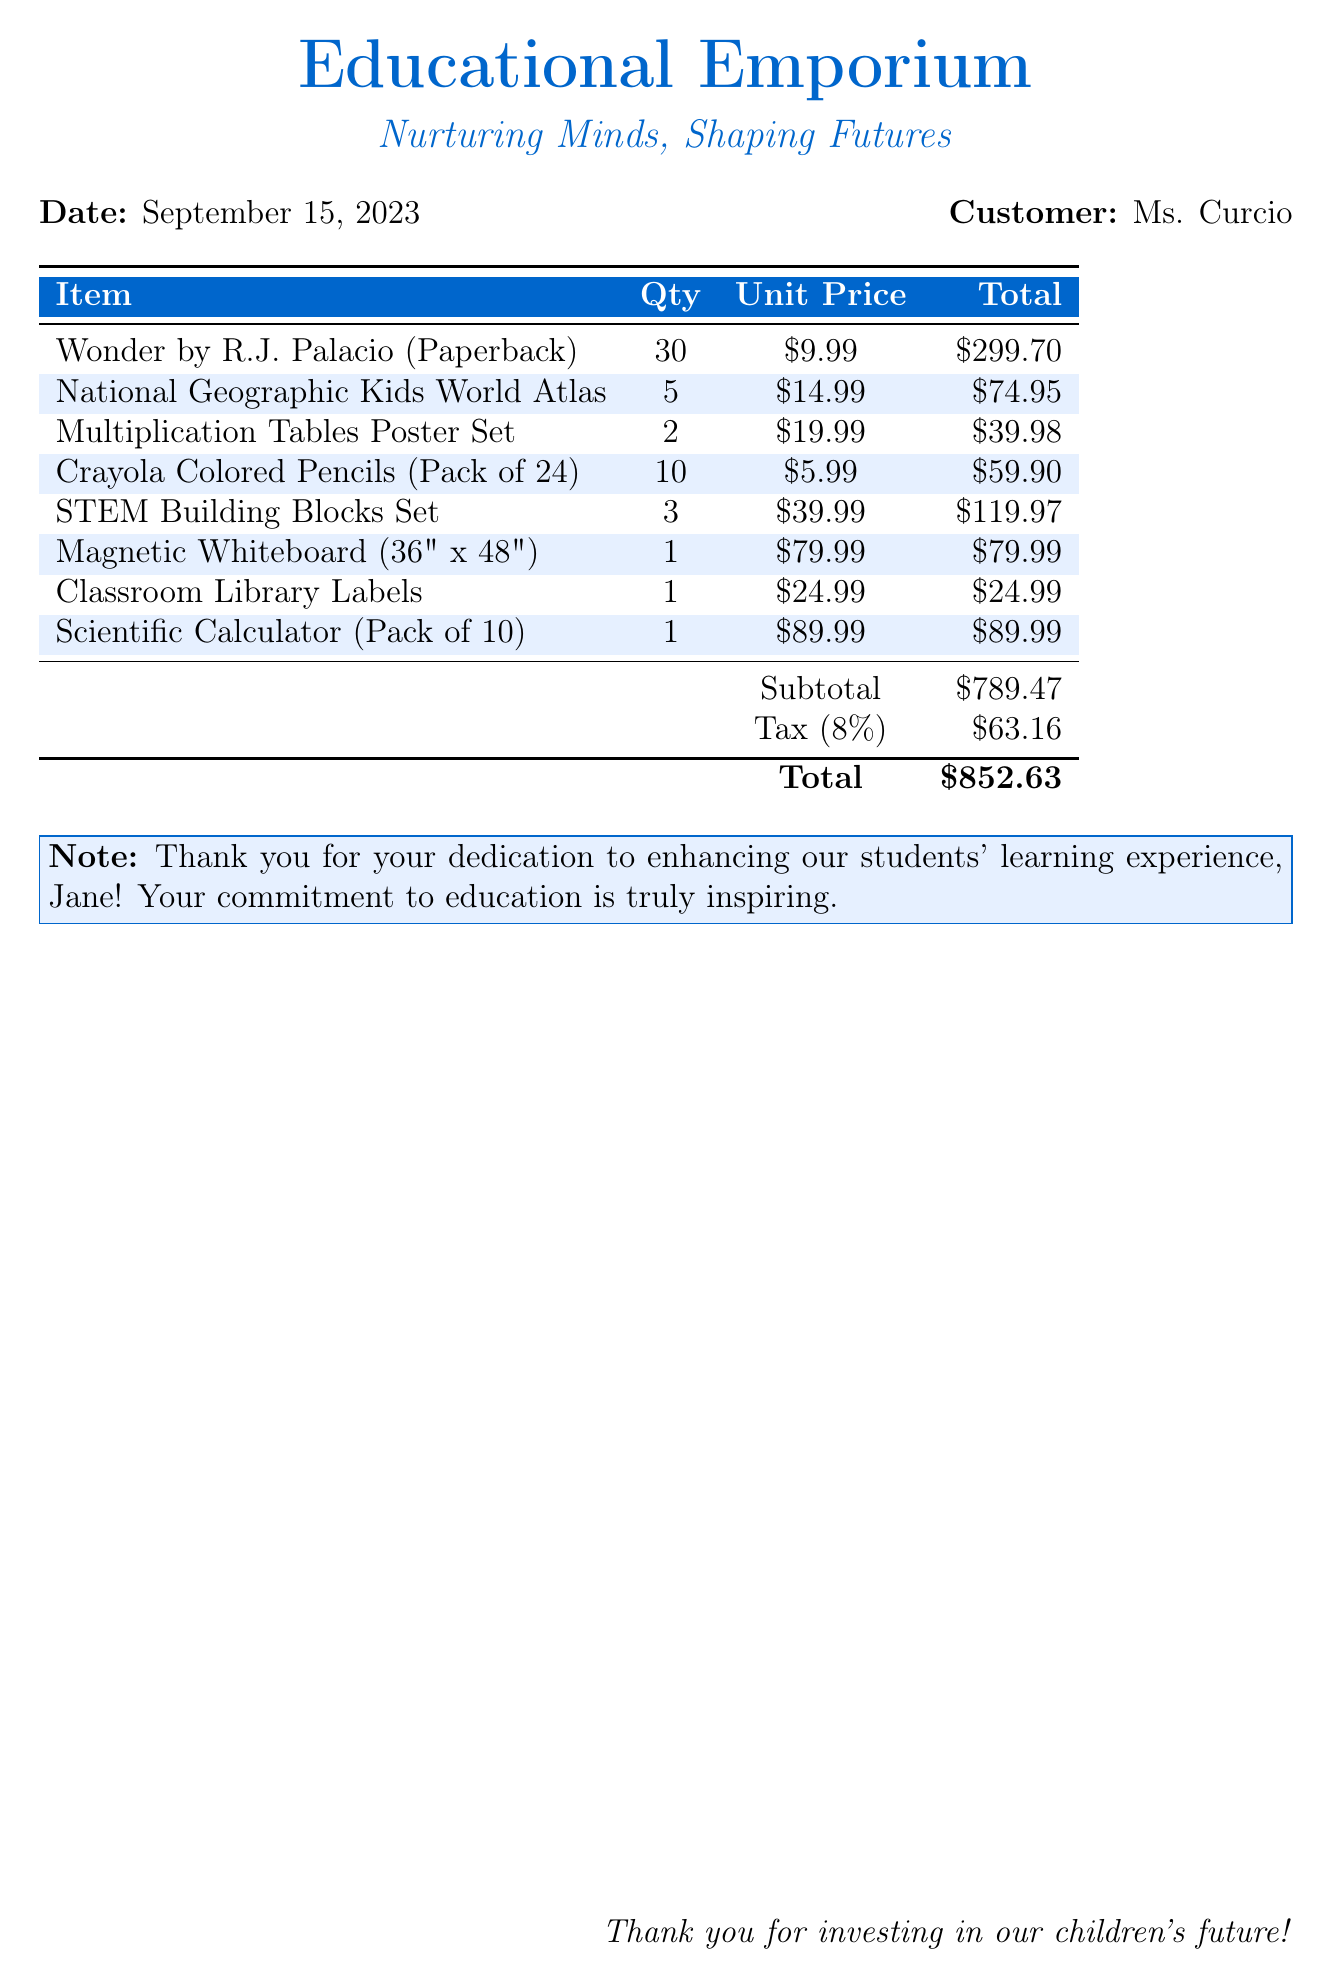What is the date of the bill? The date of the bill is explicitly stated in the document, which is September 15, 2023.
Answer: September 15, 2023 Who is the customer for this bill? The document clearly indicates the customer, which is Ms. Curcio.
Answer: Ms. Curcio What is the subtotal amount? The subtotal is provided in the document, which sums the costs of the items before tax, totaling $789.47.
Answer: $789.47 What is the tax rate applied? The tax is mentioned in the document as a percentage, which is 8%.
Answer: 8% How many copies of "Wonder" were purchased? The document lists the quantity of "Wonder by R.J. Palacio" as 30.
Answer: 30 What is the total amount for the bill? The total amount at the bottom of the document reflects the final cost, which is $852.63.
Answer: $852.63 What item has the highest unit price? The document provides prices for all items, with the Scientific Calculator being the item with the highest unit price at $89.99.
Answer: Scientific Calculator How many items were labeled as light blue in the bill? The document shows a total of 4 items that are highlighted in light blue within the list.
Answer: 4 What is noted at the bottom of the bill? There is a specific thank you note addressing Ms. Curcio for her dedication to education.
Answer: Thank you for your dedication to enhancing our students' learning experience, Jane! 